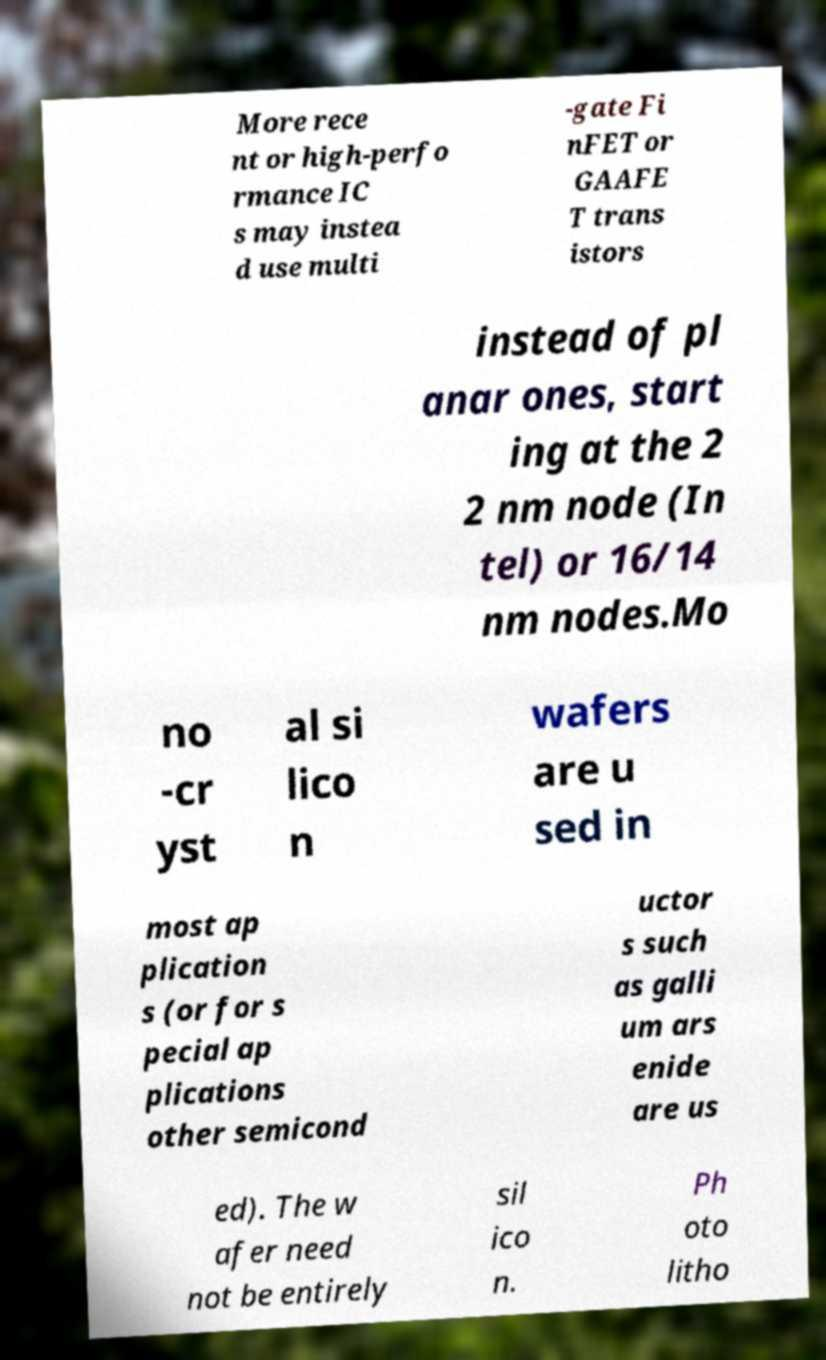Can you read and provide the text displayed in the image?This photo seems to have some interesting text. Can you extract and type it out for me? More rece nt or high-perfo rmance IC s may instea d use multi -gate Fi nFET or GAAFE T trans istors instead of pl anar ones, start ing at the 2 2 nm node (In tel) or 16/14 nm nodes.Mo no -cr yst al si lico n wafers are u sed in most ap plication s (or for s pecial ap plications other semicond uctor s such as galli um ars enide are us ed). The w afer need not be entirely sil ico n. Ph oto litho 